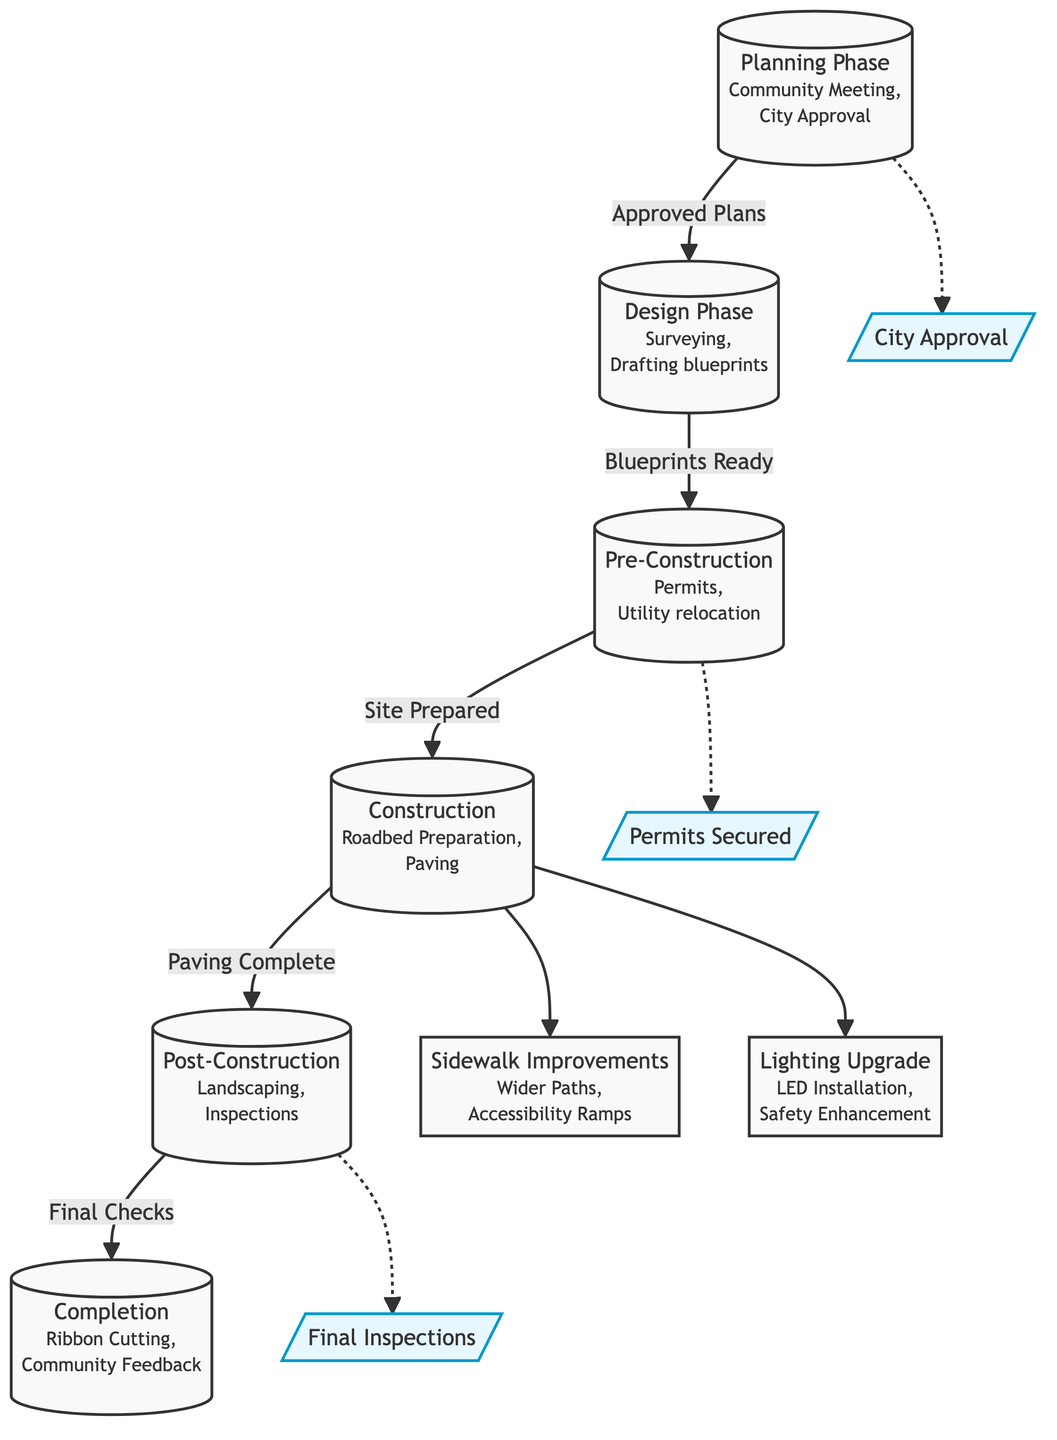What is the first phase in the road construction timeline? The first phase indicated in the diagram is the "Planning Phase." It is the starting point of the timeline and is represented at the top of the flowchart.
Answer: Planning Phase How many milestones are shown in the diagram? There are three milestones indicated in the diagram: "City Approval," "Permits Secured," and "Final Inspections." They are marked as dashed lines and are connected to specific phases in the process.
Answer: 3 Which phase follows the "Design Phase"? The phase that follows the "Design Phase" is the "Pre-Construction" phase. The connection flows directly downward from one to the other in the diagram.
Answer: Pre-Construction What is one of the improvements made during the "Construction" phase? One of the improvements made during the "Construction" phase is "Lighting Upgrade," which involves LED installation and safety enhancement. This improvement is shown as an output from the construction phase.
Answer: Lighting Upgrade What comes after "Post-Construction" phase in the timeline? After the "Post-Construction" phase, the next step in the timeline is "Completion." This is indicated by a direct flow connection between the two phases in the diagram.
Answer: Completion What is needed before moving from the "Planning Phase" to the "Design Phase"? Before moving from the "Planning Phase" to the "Design Phase," the plans must be approved. This transition is indicated with a label showing "Approved Plans" connecting the two phases.
Answer: Approved Plans Which phase involves community feedback as part of its activities? The "Completion" phase involves community feedback. This is specified in the description of activities under the "Completion" node in the diagram.
Answer: Completion Name one activity that occurs during the "Pre-Construction" phase. One of the activities that occurs during the "Pre-Construction" phase is "Utility relocation." It is listed as one of the key actions taken during this phase.
Answer: Utility relocation 